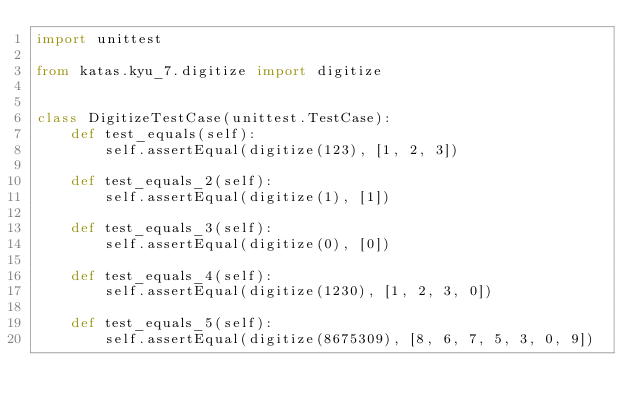<code> <loc_0><loc_0><loc_500><loc_500><_Python_>import unittest

from katas.kyu_7.digitize import digitize


class DigitizeTestCase(unittest.TestCase):
    def test_equals(self):
        self.assertEqual(digitize(123), [1, 2, 3])

    def test_equals_2(self):
        self.assertEqual(digitize(1), [1])

    def test_equals_3(self):
        self.assertEqual(digitize(0), [0])

    def test_equals_4(self):
        self.assertEqual(digitize(1230), [1, 2, 3, 0])

    def test_equals_5(self):
        self.assertEqual(digitize(8675309), [8, 6, 7, 5, 3, 0, 9])
</code> 